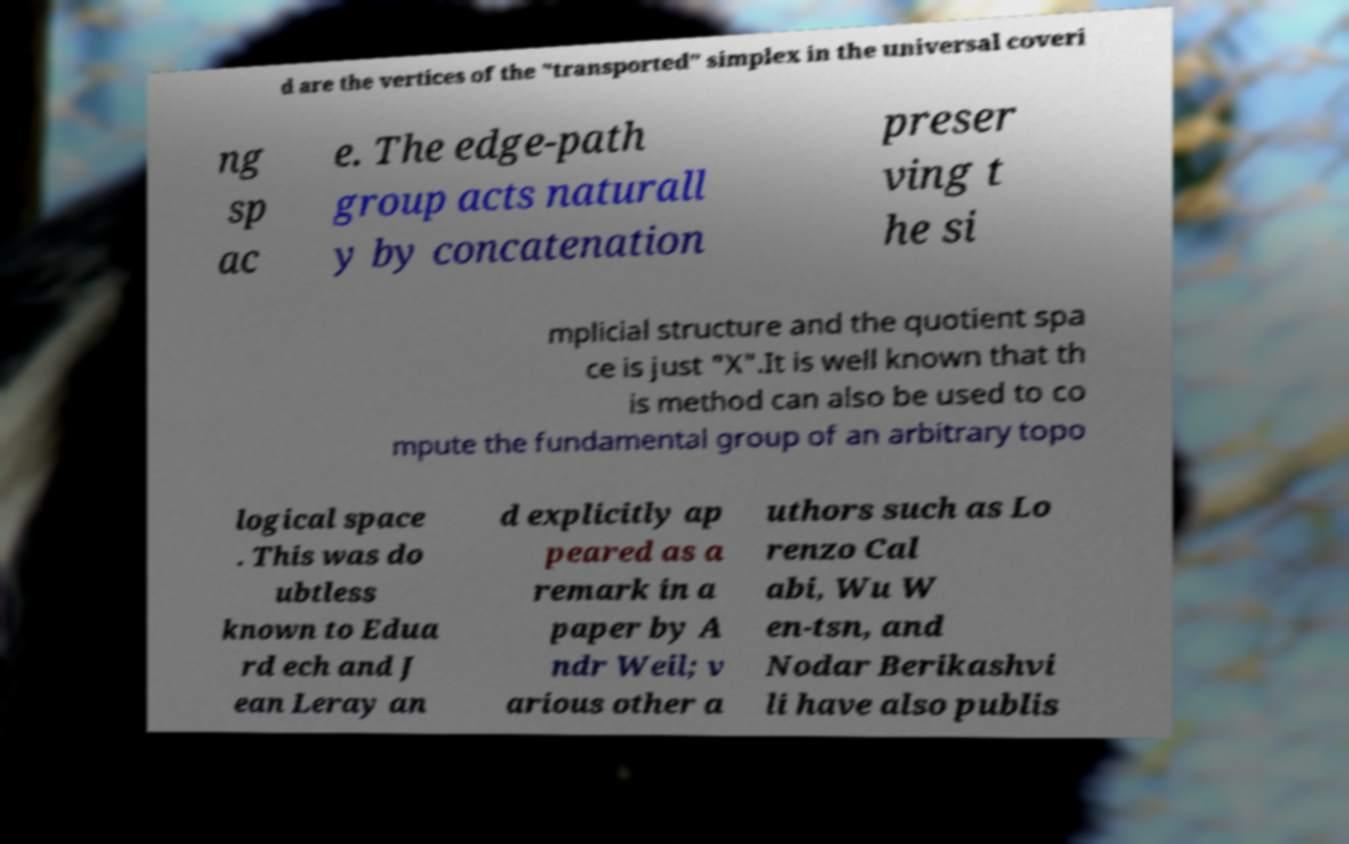Can you read and provide the text displayed in the image?This photo seems to have some interesting text. Can you extract and type it out for me? d are the vertices of the "transported" simplex in the universal coveri ng sp ac e. The edge-path group acts naturall y by concatenation preser ving t he si mplicial structure and the quotient spa ce is just "X".It is well known that th is method can also be used to co mpute the fundamental group of an arbitrary topo logical space . This was do ubtless known to Edua rd ech and J ean Leray an d explicitly ap peared as a remark in a paper by A ndr Weil; v arious other a uthors such as Lo renzo Cal abi, Wu W en-tsn, and Nodar Berikashvi li have also publis 